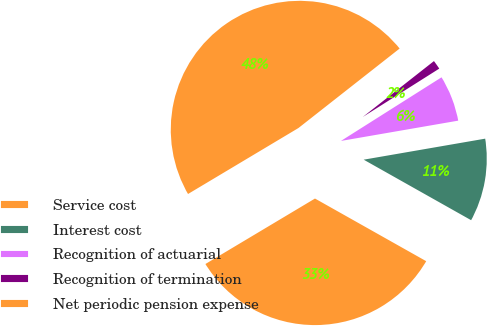Convert chart to OTSL. <chart><loc_0><loc_0><loc_500><loc_500><pie_chart><fcel>Service cost<fcel>Interest cost<fcel>Recognition of actuarial<fcel>Recognition of termination<fcel>Net periodic pension expense<nl><fcel>33.26%<fcel>10.89%<fcel>6.25%<fcel>1.62%<fcel>47.97%<nl></chart> 